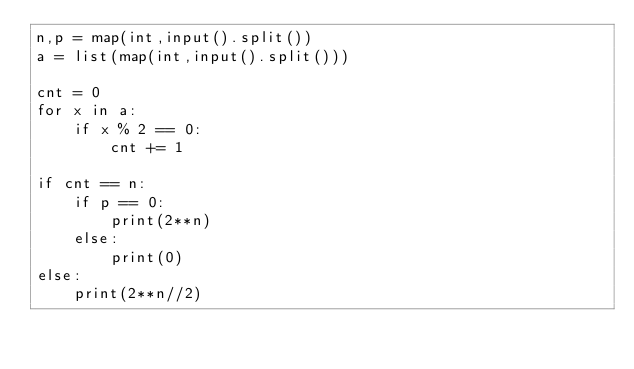Convert code to text. <code><loc_0><loc_0><loc_500><loc_500><_Python_>n,p = map(int,input().split())
a = list(map(int,input().split()))

cnt = 0
for x in a:
    if x % 2 == 0:
        cnt += 1
        
if cnt == n:
    if p == 0:
        print(2**n)
    else:
        print(0)
else:
    print(2**n//2)</code> 